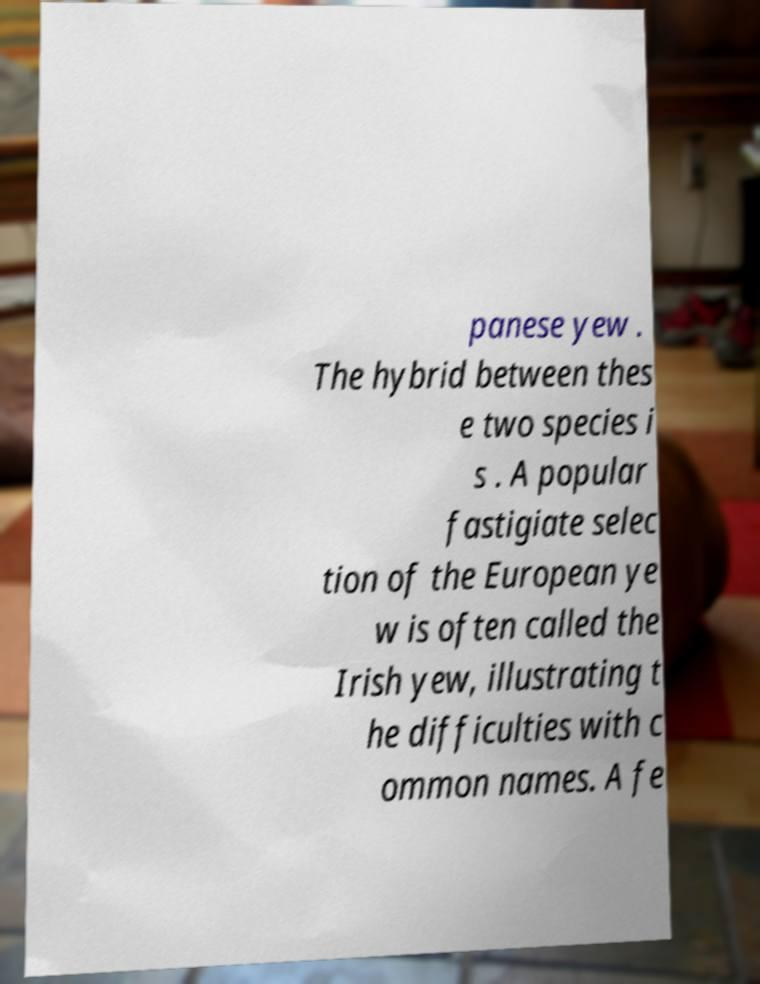I need the written content from this picture converted into text. Can you do that? panese yew . The hybrid between thes e two species i s . A popular fastigiate selec tion of the European ye w is often called the Irish yew, illustrating t he difficulties with c ommon names. A fe 